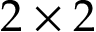<formula> <loc_0><loc_0><loc_500><loc_500>2 \times 2</formula> 